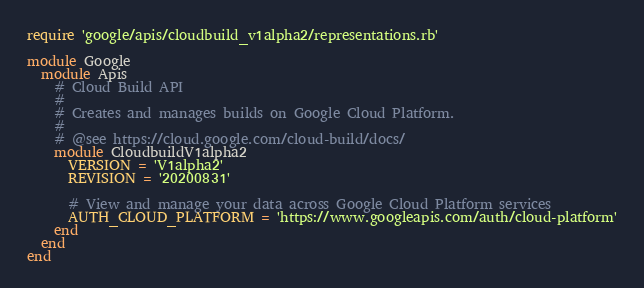<code> <loc_0><loc_0><loc_500><loc_500><_Ruby_>require 'google/apis/cloudbuild_v1alpha2/representations.rb'

module Google
  module Apis
    # Cloud Build API
    #
    # Creates and manages builds on Google Cloud Platform.
    #
    # @see https://cloud.google.com/cloud-build/docs/
    module CloudbuildV1alpha2
      VERSION = 'V1alpha2'
      REVISION = '20200831'

      # View and manage your data across Google Cloud Platform services
      AUTH_CLOUD_PLATFORM = 'https://www.googleapis.com/auth/cloud-platform'
    end
  end
end
</code> 